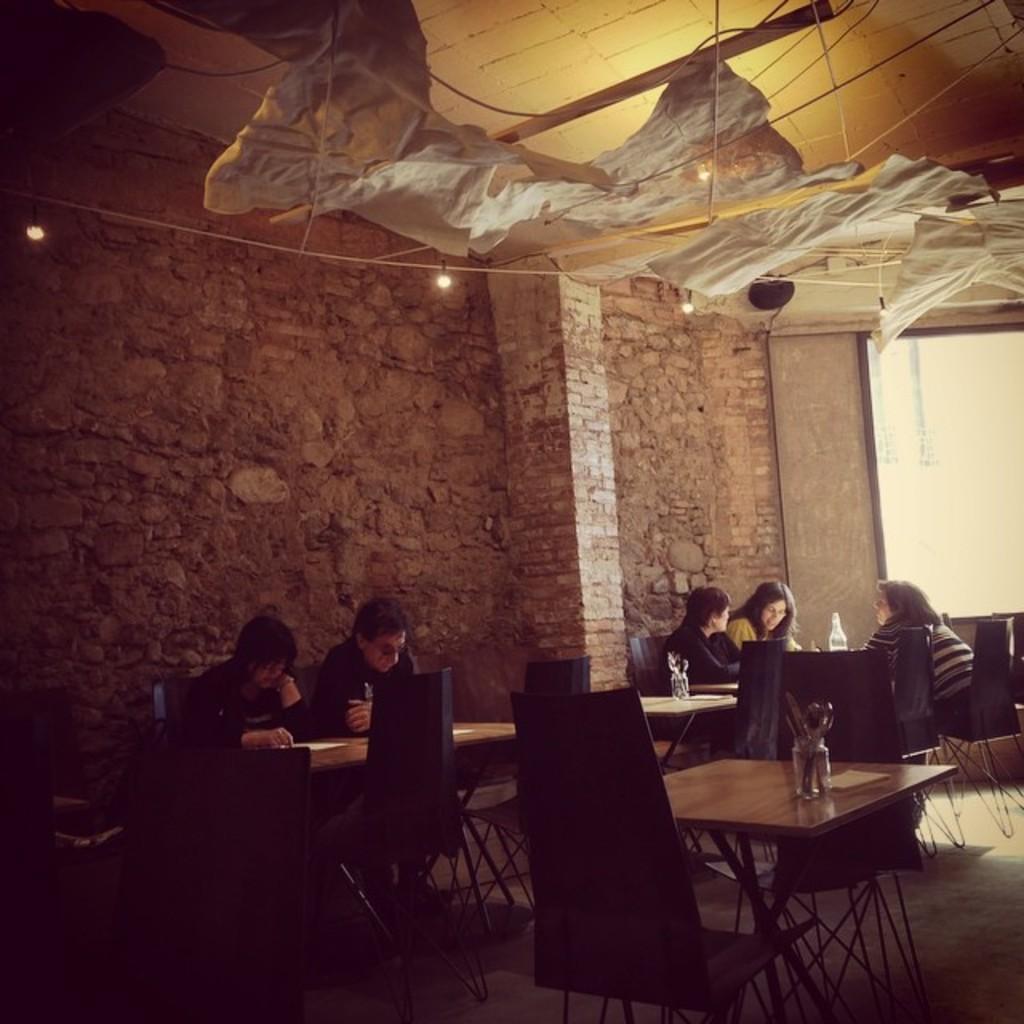Can you describe this image briefly? people are sitting on the chairs. behind them there is a brick wall. 